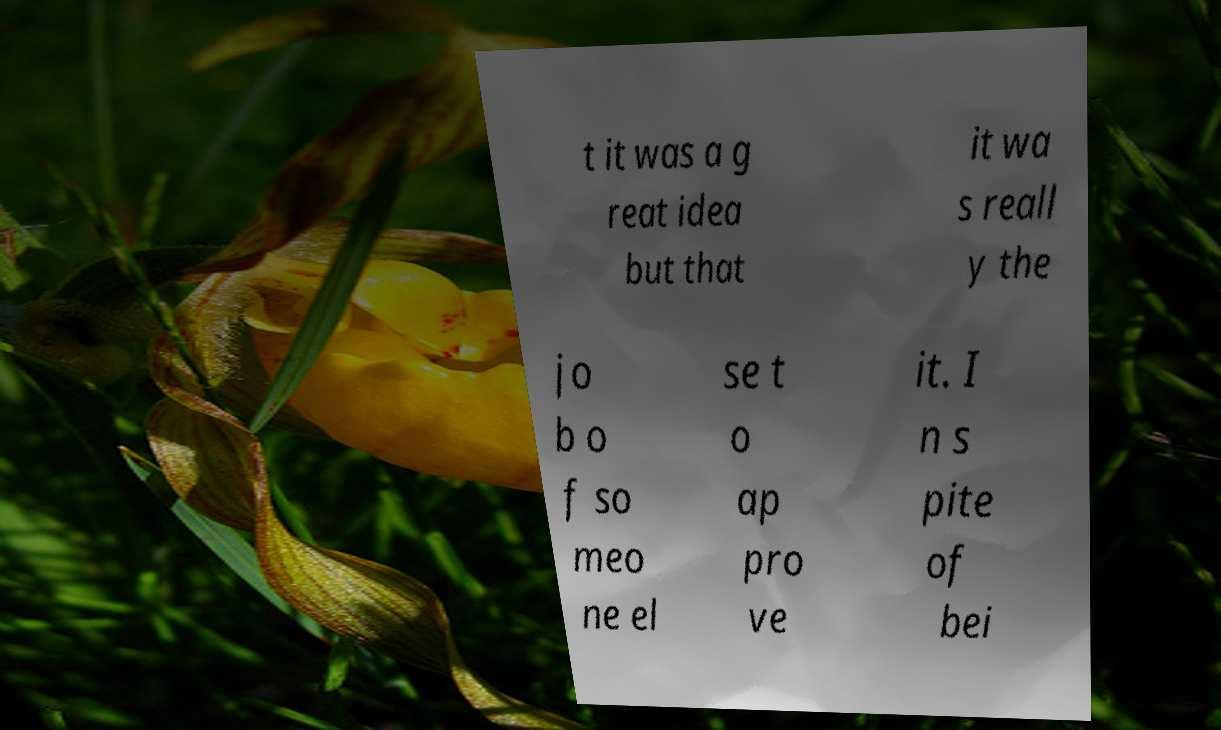Please read and relay the text visible in this image. What does it say? t it was a g reat idea but that it wa s reall y the jo b o f so meo ne el se t o ap pro ve it. I n s pite of bei 